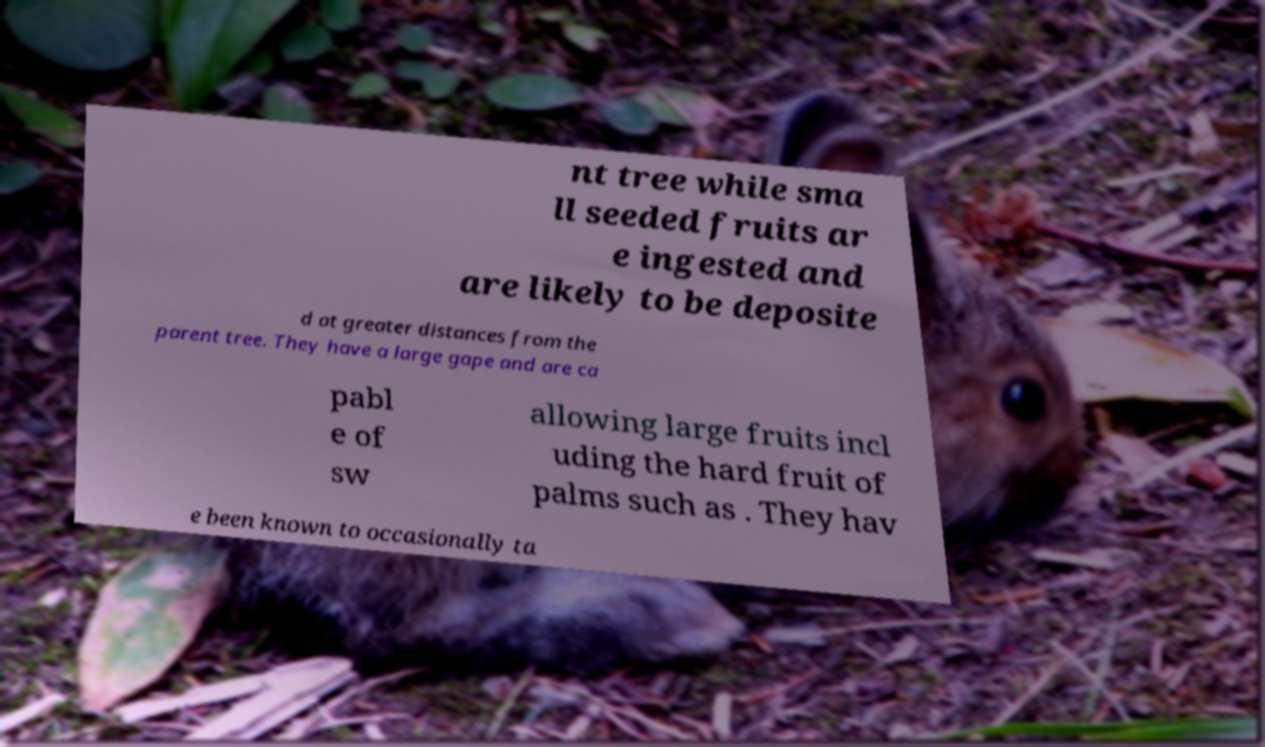What messages or text are displayed in this image? I need them in a readable, typed format. nt tree while sma ll seeded fruits ar e ingested and are likely to be deposite d at greater distances from the parent tree. They have a large gape and are ca pabl e of sw allowing large fruits incl uding the hard fruit of palms such as . They hav e been known to occasionally ta 